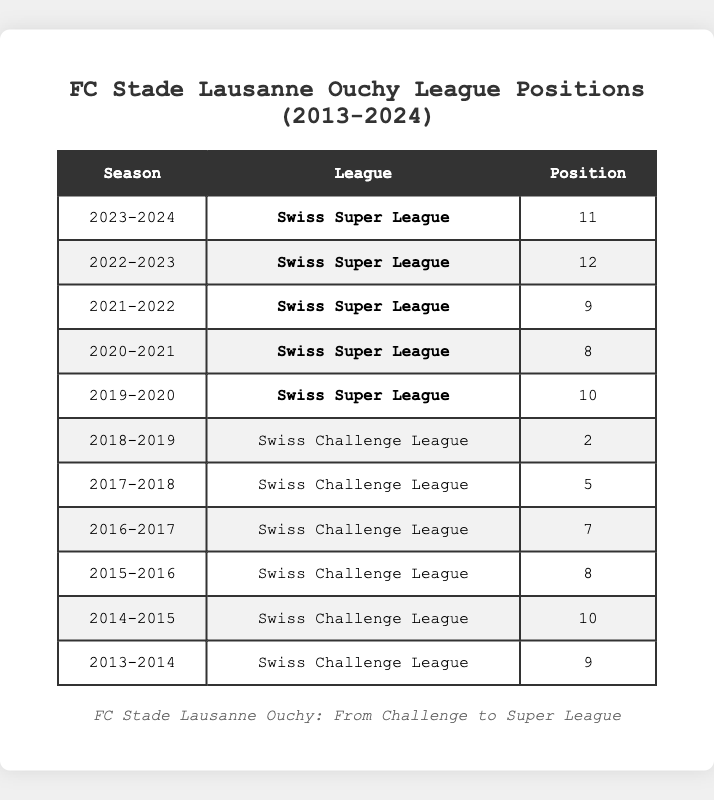What was FC Stade Lausanne Ouchy's league position in the 2018-2019 season? The table shows that in the 2018-2019 season, the league position was 2.
Answer: 2 What position did FC Stade Lausanne Ouchy achieve in the Swiss Super League in the 2020-2021 season? According to the table, the position was 8 in the 2020-2021 season.
Answer: 8 How many times did FC Stade Lausanne Ouchy finish in the top 5 of the league in the last decade? The positions in the top 5 are from 2017-2018 (5th) and 2018-2019 (2nd). Therefore, FC Stade Lausanne Ouchy finished in the top 5 twice in the last decade.
Answer: 2 What is the average league position of FC Stade Lausanne Ouchy in the Super League seasons listed? The positions in the Super League are 10, 8, 9, 12, and 11. The sum of these positions is 60, and there are 5 seasons, so the average is 60/5 = 12. Therefore, the average position is 12.
Answer: 12 Did FC Stade Lausanne Ouchy perform better in the Swiss Challenge League or the Swiss Super League based on their highest positions? The best position in the Swiss Challenge League was 2 in the 2018-2019 season, while the best position in the Swiss Super League was 8. Since 2 is better than 8, they performed better in the Challenge League.
Answer: Yes What was the difference in league position from the 2017-2018 season to the 2018-2019 season? The position in 2017-2018 was 5 and in 2018-2019 was 2. The difference is 5 - 2 = 3 positions higher in 2018-2019.
Answer: 3 In which season did FC Stade Lausanne Ouchy have their worst performance, and what was their position? The worst performance was in the 2022-2023 season with a position of 12.
Answer: 12 How many years did FC Stade Lausanne Ouchy spend in the Swiss Challenge League during the last decade? They spent the seasons from 2013-2014 to 2018-2019 which totals 6 seasons in the Swiss Challenge League.
Answer: 6 What trend can be seen in the league positions from 2013 to 2019? The trend shows an overall improvement from positions 10, 9, 8, 7, 5 and then a peak position of 2 in 2018-2019.
Answer: Improvement What was FC Stade Lausanne Ouchy's league position in 2019-2020 after being promoted to the Super League? The position was 10 in the 2019-2020 season according to the table.
Answer: 10 Compare the league positions from the 2013-2014 to the 2023-2024 season, what can be said about the overall performance? The position declined from a 9th in 2013-2014 to mostly the bottom half in subsequent Super League seasons, indicating a decline.
Answer: Decline 